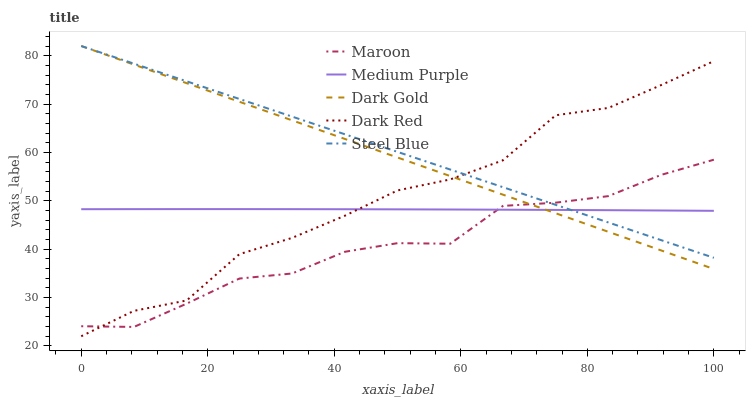Does Maroon have the minimum area under the curve?
Answer yes or no. Yes. Does Steel Blue have the maximum area under the curve?
Answer yes or no. Yes. Does Dark Red have the minimum area under the curve?
Answer yes or no. No. Does Dark Red have the maximum area under the curve?
Answer yes or no. No. Is Dark Gold the smoothest?
Answer yes or no. Yes. Is Dark Red the roughest?
Answer yes or no. Yes. Is Steel Blue the smoothest?
Answer yes or no. No. Is Steel Blue the roughest?
Answer yes or no. No. Does Steel Blue have the lowest value?
Answer yes or no. No. Does Dark Gold have the highest value?
Answer yes or no. Yes. Does Dark Red have the highest value?
Answer yes or no. No. Does Dark Gold intersect Medium Purple?
Answer yes or no. Yes. Is Dark Gold less than Medium Purple?
Answer yes or no. No. Is Dark Gold greater than Medium Purple?
Answer yes or no. No. 